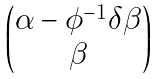Convert formula to latex. <formula><loc_0><loc_0><loc_500><loc_500>\begin{pmatrix} \alpha - \phi ^ { - 1 } \delta \beta \\ \beta \end{pmatrix}</formula> 